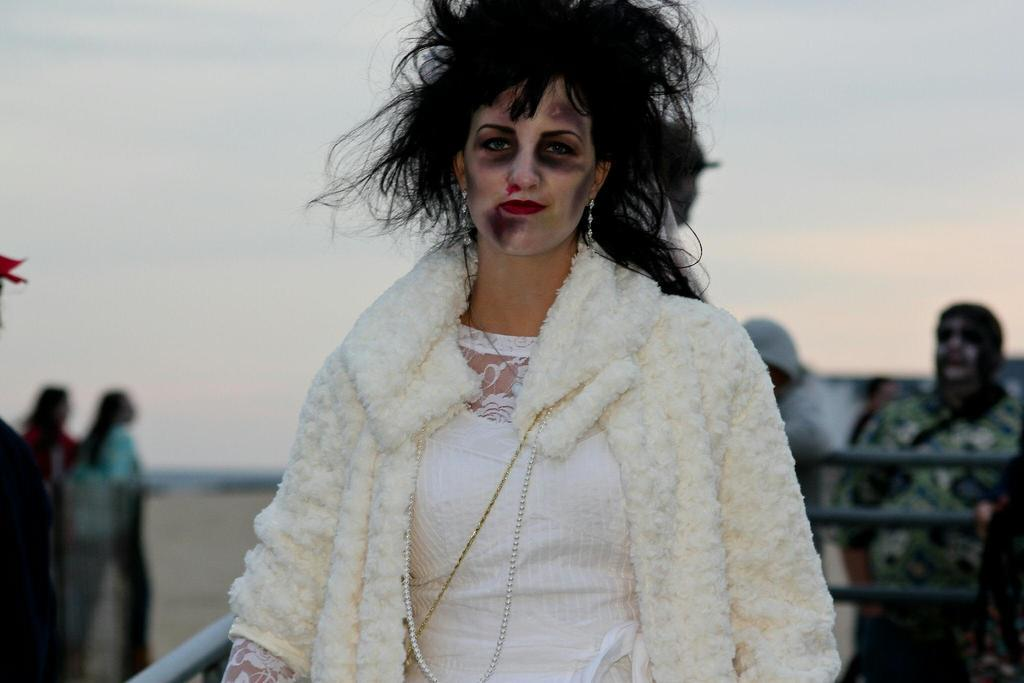What is the main subject of the image? There is a person in the image. What is the person wearing? The person is wearing a white dress. Can you describe the background of the image? There are other persons visible in the background. What is the color of the sky in the image? The sky is white in color. What type of liquid can be seen flowing from the person's dress in the image? There is no liquid flowing from the person's dress in the image. What religious symbol is present in the image? There is no religious symbol present in the image. Is there a boat visible in the image? There is no boat visible in the image. 